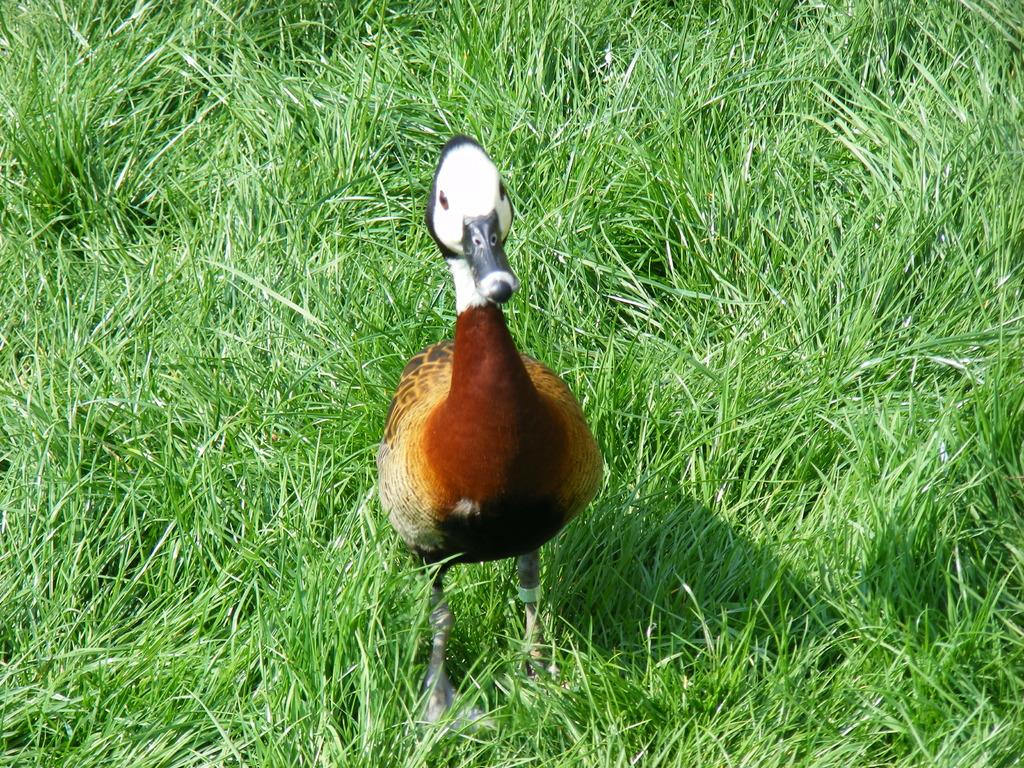What type of animal can be seen in the image? There is a bird in the image. What is visible in the background of the image? There is grass visible in the background of the image. What type of coast can be seen in the image? There is no coast visible in the image; it features a bird and grass in the background. Is there a zipper on the bird's leg in the image? There is no bird with a zipper on its leg in the image; it simply shows a bird in its natural state. 